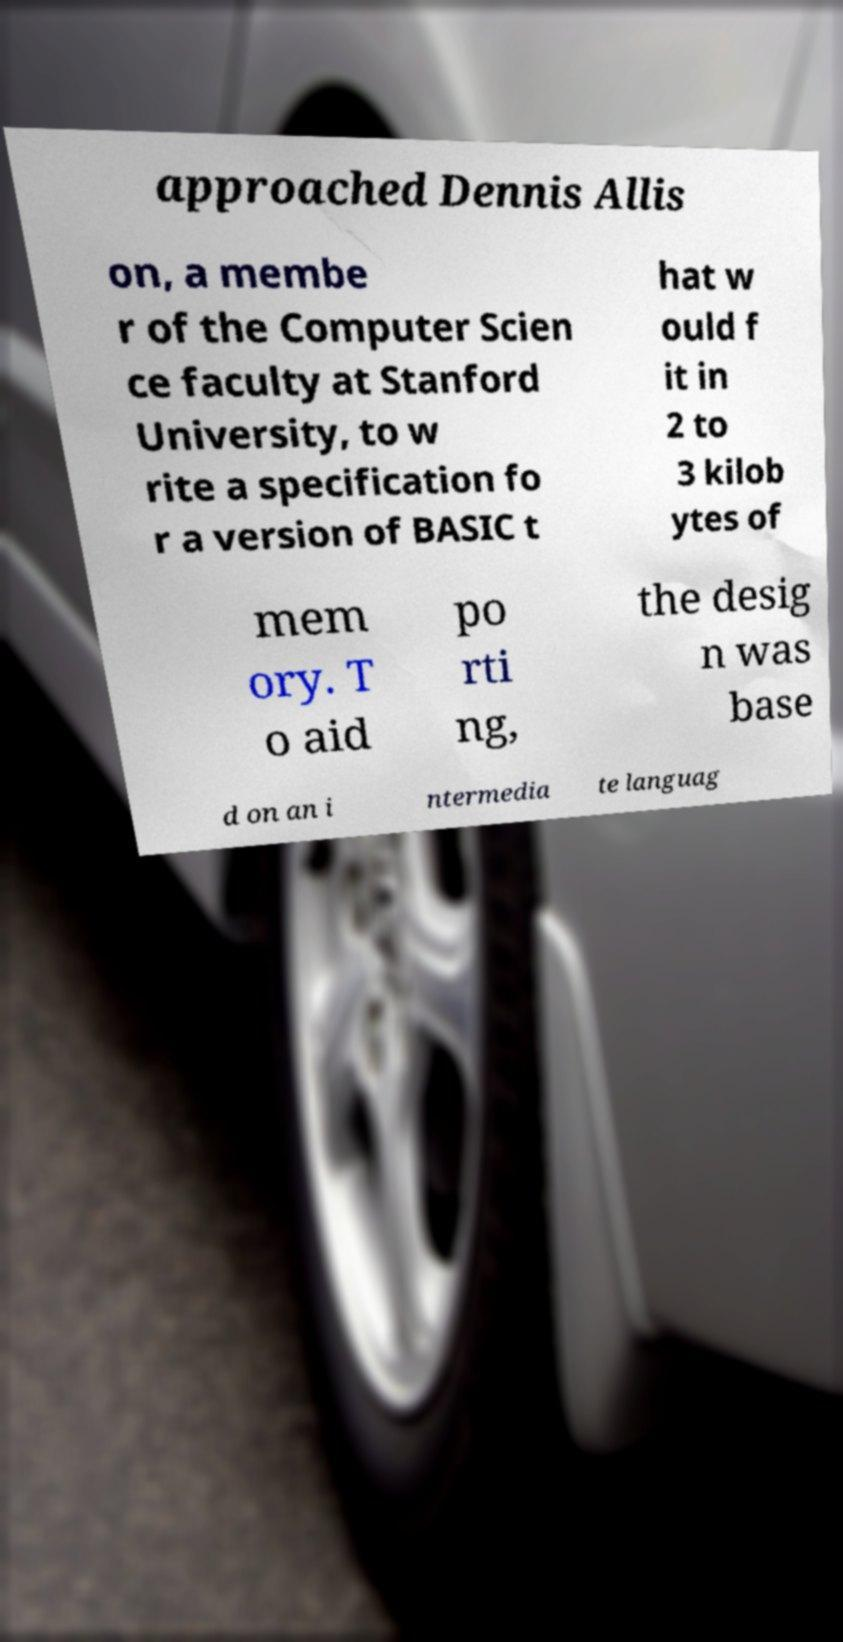For documentation purposes, I need the text within this image transcribed. Could you provide that? approached Dennis Allis on, a membe r of the Computer Scien ce faculty at Stanford University, to w rite a specification fo r a version of BASIC t hat w ould f it in 2 to 3 kilob ytes of mem ory. T o aid po rti ng, the desig n was base d on an i ntermedia te languag 